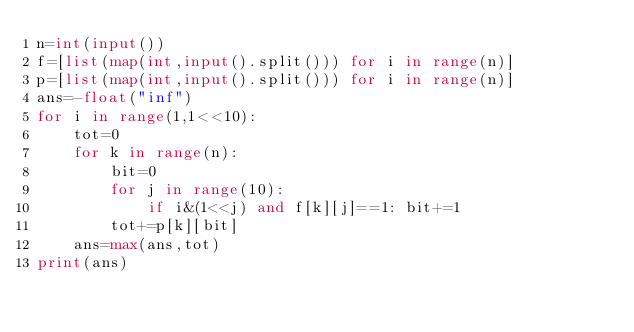<code> <loc_0><loc_0><loc_500><loc_500><_Python_>n=int(input())
f=[list(map(int,input().split())) for i in range(n)]
p=[list(map(int,input().split())) for i in range(n)]
ans=-float("inf")
for i in range(1,1<<10):
    tot=0
    for k in range(n):
        bit=0
        for j in range(10):
            if i&(1<<j) and f[k][j]==1: bit+=1
        tot+=p[k][bit]
    ans=max(ans,tot)
print(ans)</code> 